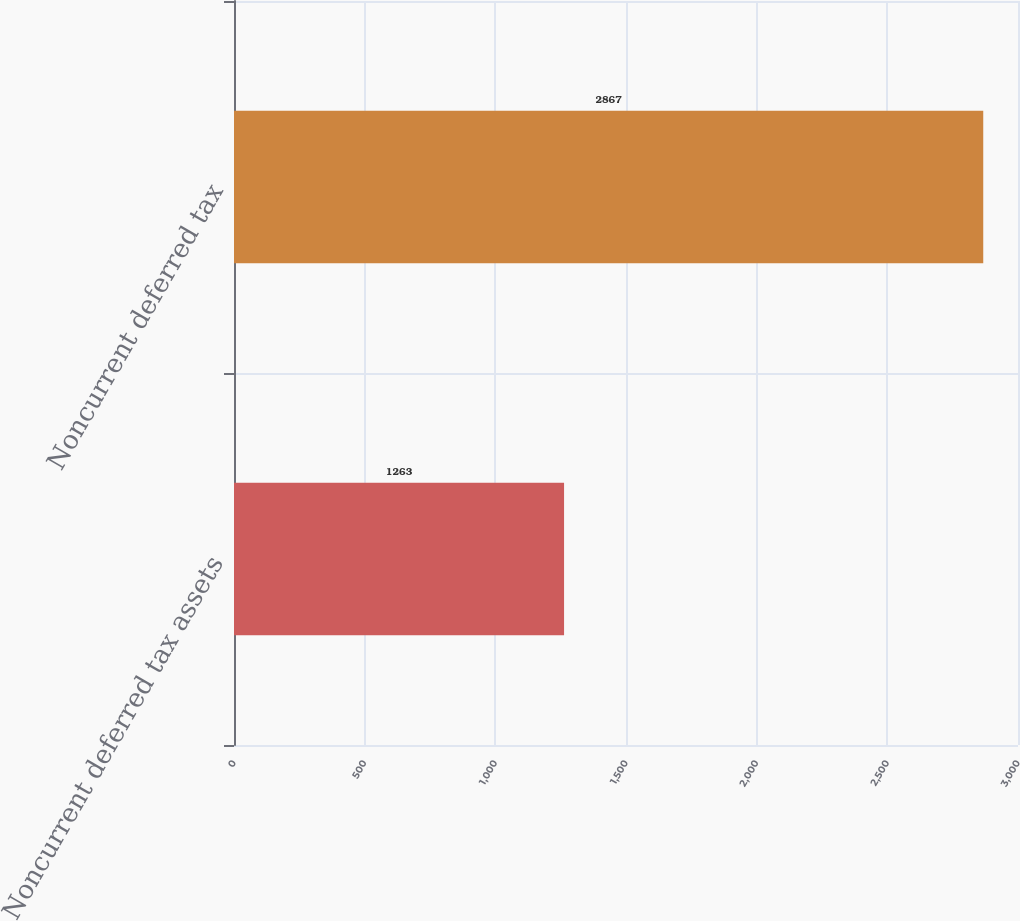Convert chart to OTSL. <chart><loc_0><loc_0><loc_500><loc_500><bar_chart><fcel>Noncurrent deferred tax assets<fcel>Noncurrent deferred tax<nl><fcel>1263<fcel>2867<nl></chart> 